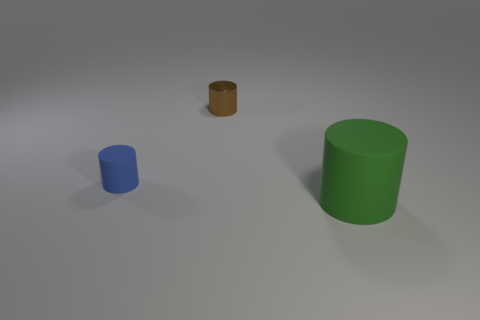How many things are either tiny red rubber balls or matte cylinders?
Keep it short and to the point. 2. What number of other objects are there of the same shape as the blue matte object?
Make the answer very short. 2. Is the small thing that is in front of the tiny brown metallic cylinder made of the same material as the tiny cylinder right of the small blue rubber object?
Provide a short and direct response. No. There is a thing that is to the right of the tiny blue cylinder and left of the green thing; what shape is it?
Provide a succinct answer. Cylinder. Is there any other thing that has the same material as the brown object?
Offer a very short reply. No. There is a object that is in front of the brown metallic cylinder and to the right of the small blue rubber object; what is its material?
Offer a very short reply. Rubber. The blue thing that is the same material as the large green cylinder is what shape?
Make the answer very short. Cylinder. Is the number of small blue cylinders that are on the left side of the small blue object greater than the number of small shiny cylinders?
Your response must be concise. No. What material is the large green cylinder?
Provide a succinct answer. Rubber. What number of blue cylinders have the same size as the green matte cylinder?
Offer a terse response. 0. 